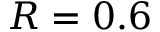<formula> <loc_0><loc_0><loc_500><loc_500>R = 0 . 6</formula> 